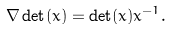Convert formula to latex. <formula><loc_0><loc_0><loc_500><loc_500>\nabla \det ( x ) = \det ( x ) x ^ { - 1 } .</formula> 